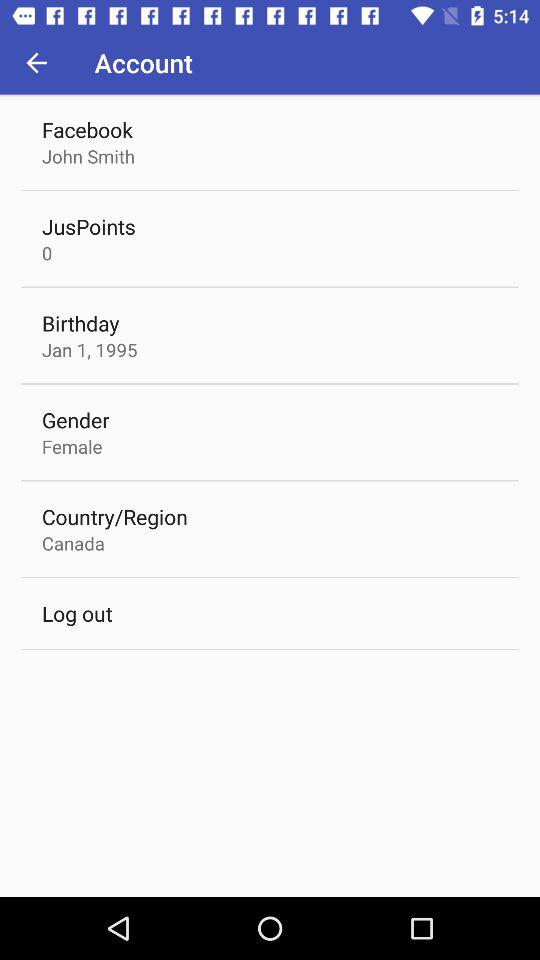What is the gender? The gender is female. 